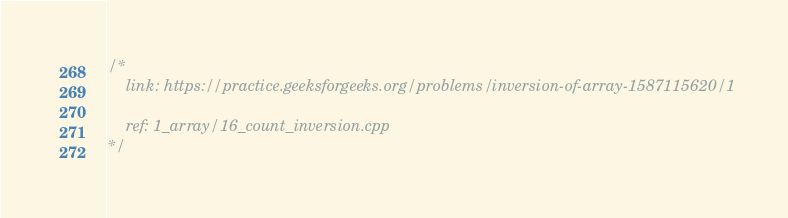<code> <loc_0><loc_0><loc_500><loc_500><_C++_>/*
    link: https://practice.geeksforgeeks.org/problems/inversion-of-array-1587115620/1

    ref: 1_array/16_count_inversion.cpp
*/
</code> 